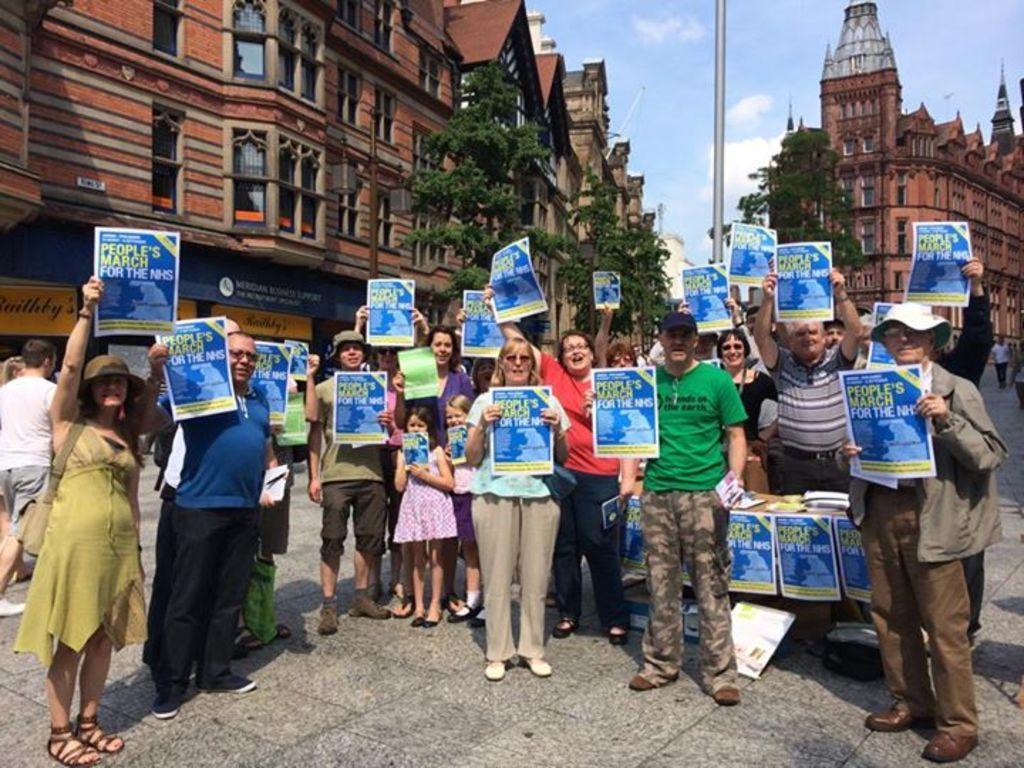In one or two sentences, can you explain what this image depicts? In this image people are holding posters on a road on that poster there is text, in the background there are trees buildings and a sky. 